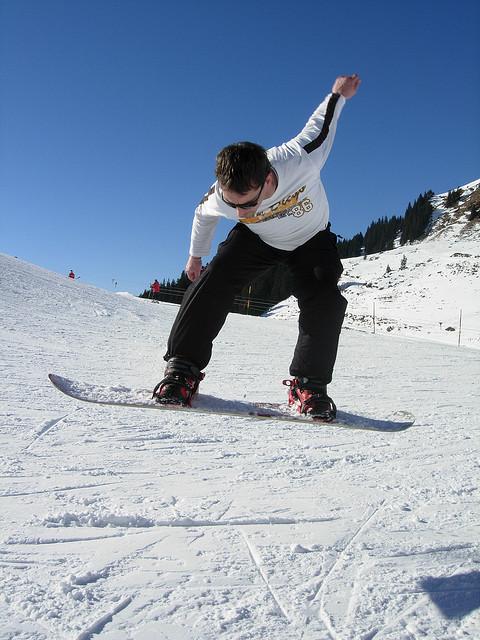Is this taking place in the summer?
Concise answer only. No. Is the man dancing?
Keep it brief. No. What color are his boots?
Give a very brief answer. Black and red. 